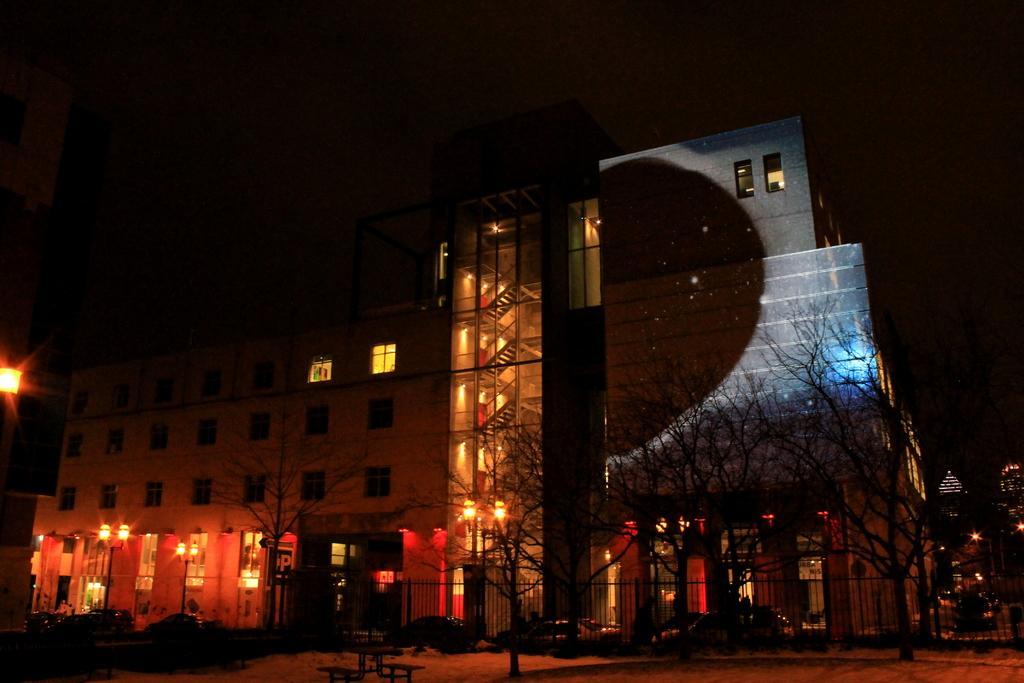Can you describe this image briefly? In this image there are buildings, trees and light poles. Image also consists of cars. Fence and bench are also visible. 